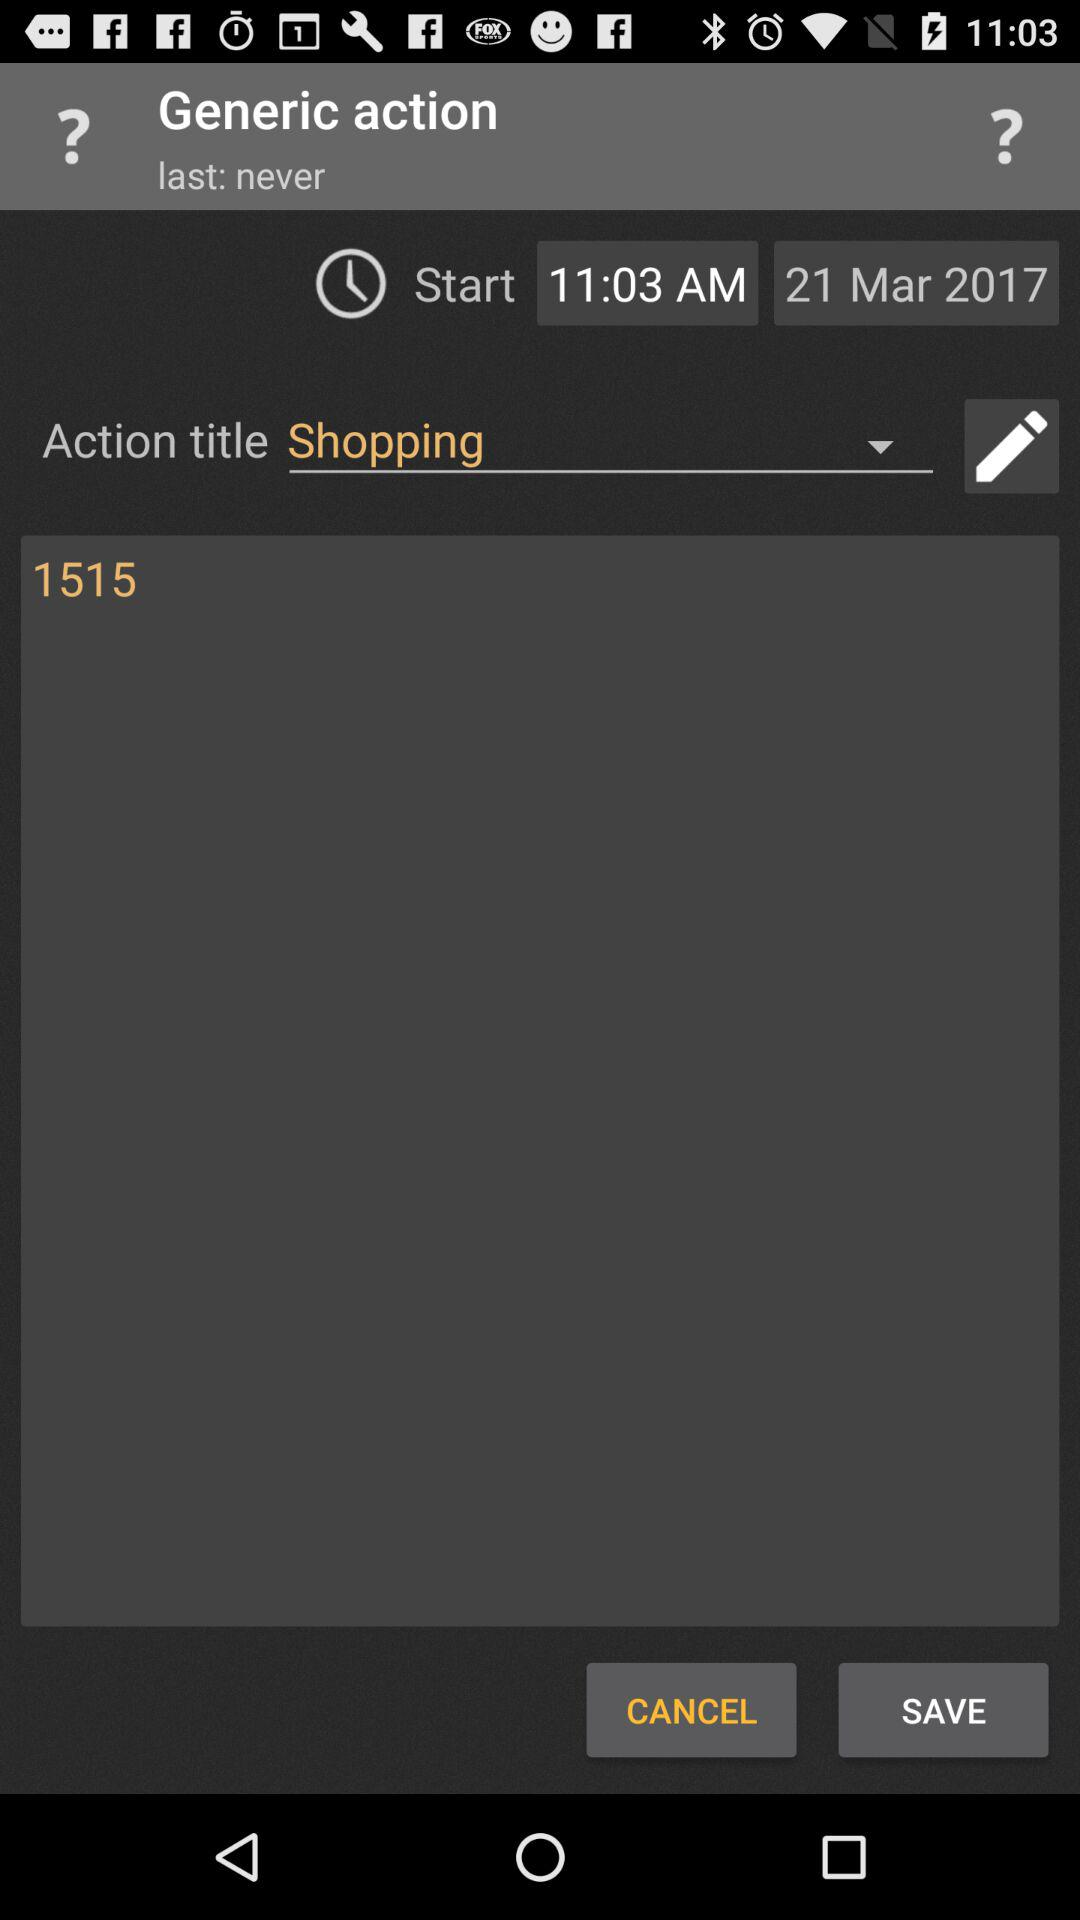What is the start time? The start time is 11:03 AM. 